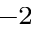<formula> <loc_0><loc_0><loc_500><loc_500>^ { - 2 }</formula> 